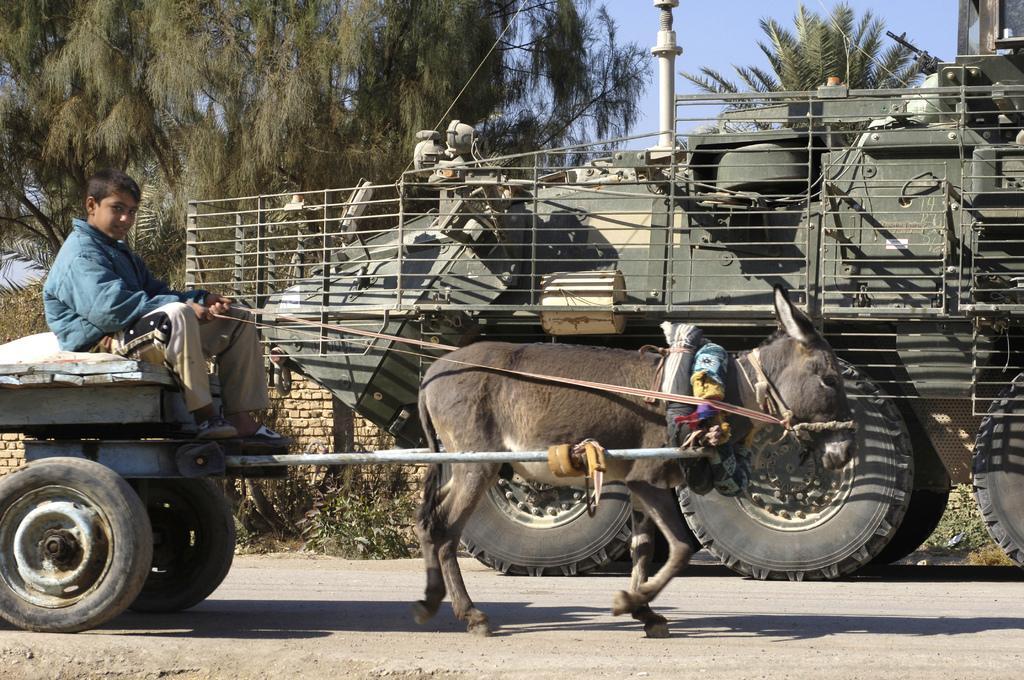In one or two sentences, can you explain what this image depicts? In this image we can see a boy sitting on a cart. There is a donkey. In the background of the image there is a war tank. There are trees. There is a pole. At the bottom of the image there is road. 